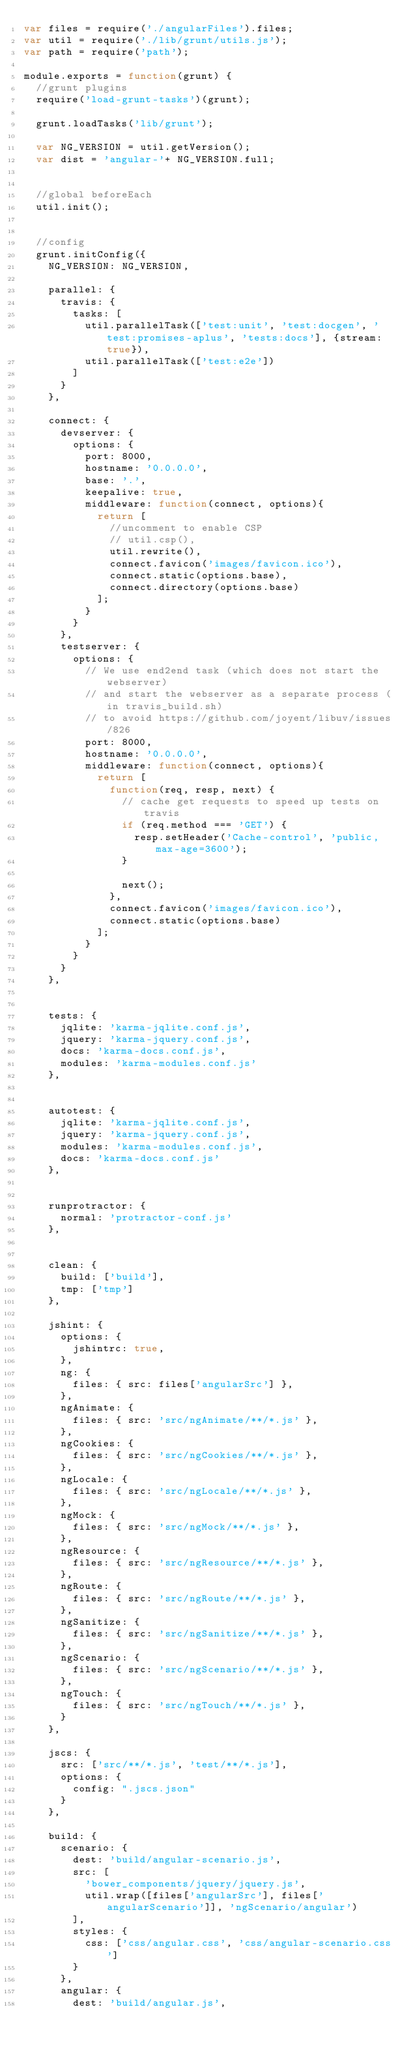Convert code to text. <code><loc_0><loc_0><loc_500><loc_500><_JavaScript_>var files = require('./angularFiles').files;
var util = require('./lib/grunt/utils.js');
var path = require('path');

module.exports = function(grunt) {
  //grunt plugins
  require('load-grunt-tasks')(grunt);

  grunt.loadTasks('lib/grunt');

  var NG_VERSION = util.getVersion();
  var dist = 'angular-'+ NG_VERSION.full;


  //global beforeEach
  util.init();


  //config
  grunt.initConfig({
    NG_VERSION: NG_VERSION,

    parallel: {
      travis: {
        tasks: [
          util.parallelTask(['test:unit', 'test:docgen', 'test:promises-aplus', 'tests:docs'], {stream: true}),
          util.parallelTask(['test:e2e'])
        ]
      }
    },

    connect: {
      devserver: {
        options: {
          port: 8000,
          hostname: '0.0.0.0',
          base: '.',
          keepalive: true,
          middleware: function(connect, options){
            return [
              //uncomment to enable CSP
              // util.csp(),
              util.rewrite(),
              connect.favicon('images/favicon.ico'),
              connect.static(options.base),
              connect.directory(options.base)
            ];
          }
        }
      },
      testserver: {
        options: {
          // We use end2end task (which does not start the webserver)
          // and start the webserver as a separate process (in travis_build.sh)
          // to avoid https://github.com/joyent/libuv/issues/826
          port: 8000,
          hostname: '0.0.0.0',
          middleware: function(connect, options){
            return [
              function(req, resp, next) {
                // cache get requests to speed up tests on travis
                if (req.method === 'GET') {
                  resp.setHeader('Cache-control', 'public, max-age=3600');
                }

                next();
              },
              connect.favicon('images/favicon.ico'),
              connect.static(options.base)
            ];
          }
        }
      }
    },


    tests: {
      jqlite: 'karma-jqlite.conf.js',
      jquery: 'karma-jquery.conf.js',
      docs: 'karma-docs.conf.js',
      modules: 'karma-modules.conf.js'
    },


    autotest: {
      jqlite: 'karma-jqlite.conf.js',
      jquery: 'karma-jquery.conf.js',
      modules: 'karma-modules.conf.js',
      docs: 'karma-docs.conf.js'
    },


    runprotractor: {
      normal: 'protractor-conf.js'
    },


    clean: {
      build: ['build'],
      tmp: ['tmp']
    },

    jshint: {
      options: {
        jshintrc: true,
      },
      ng: {
        files: { src: files['angularSrc'] },
      },
      ngAnimate: {
        files: { src: 'src/ngAnimate/**/*.js' },
      },
      ngCookies: {
        files: { src: 'src/ngCookies/**/*.js' },
      },
      ngLocale: {
        files: { src: 'src/ngLocale/**/*.js' },
      },
      ngMock: {
        files: { src: 'src/ngMock/**/*.js' },
      },
      ngResource: {
        files: { src: 'src/ngResource/**/*.js' },
      },
      ngRoute: {
        files: { src: 'src/ngRoute/**/*.js' },
      },
      ngSanitize: {
        files: { src: 'src/ngSanitize/**/*.js' },
      },
      ngScenario: {
        files: { src: 'src/ngScenario/**/*.js' },
      },
      ngTouch: {
        files: { src: 'src/ngTouch/**/*.js' },
      }
    },

    jscs: {
      src: ['src/**/*.js', 'test/**/*.js'],
      options: {
        config: ".jscs.json"
      }
    },

    build: {
      scenario: {
        dest: 'build/angular-scenario.js',
        src: [
          'bower_components/jquery/jquery.js',
          util.wrap([files['angularSrc'], files['angularScenario']], 'ngScenario/angular')
        ],
        styles: {
          css: ['css/angular.css', 'css/angular-scenario.css']
        }
      },
      angular: {
        dest: 'build/angular.js',</code> 